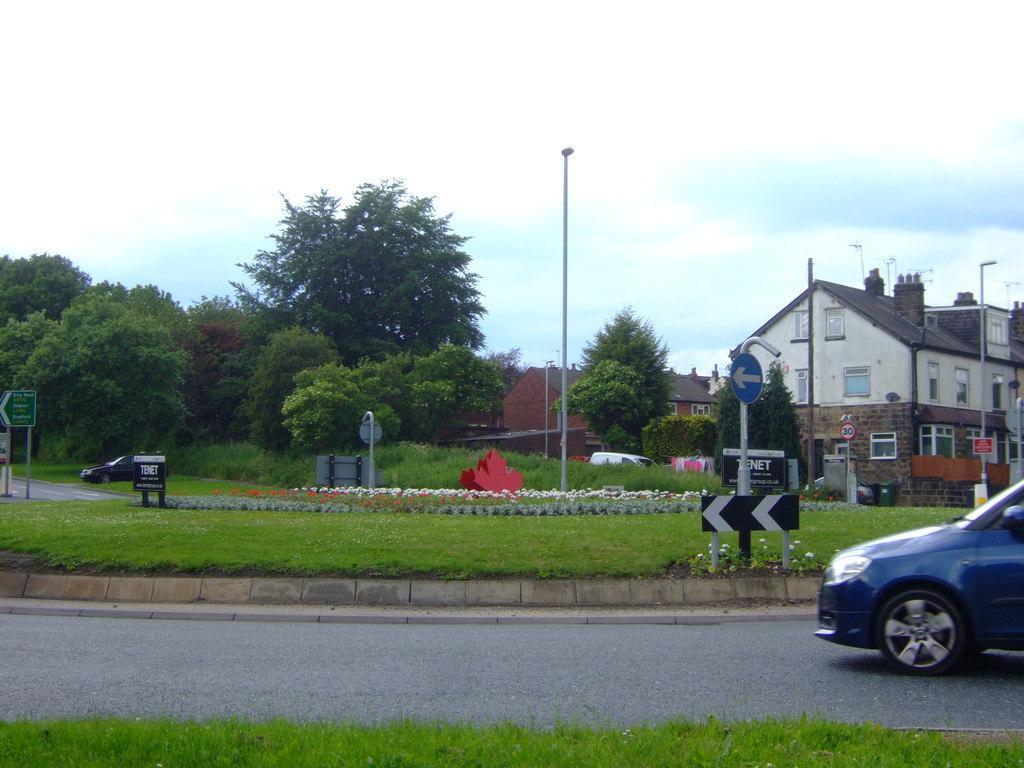Please provide a concise description of this image. In this picture I can see buildings, trees and couple of cars moving on the road and I can see few sign boards and board with some text and couple of pole lights and I can see grass and few plants with flowers and a blue cloudy sky. 